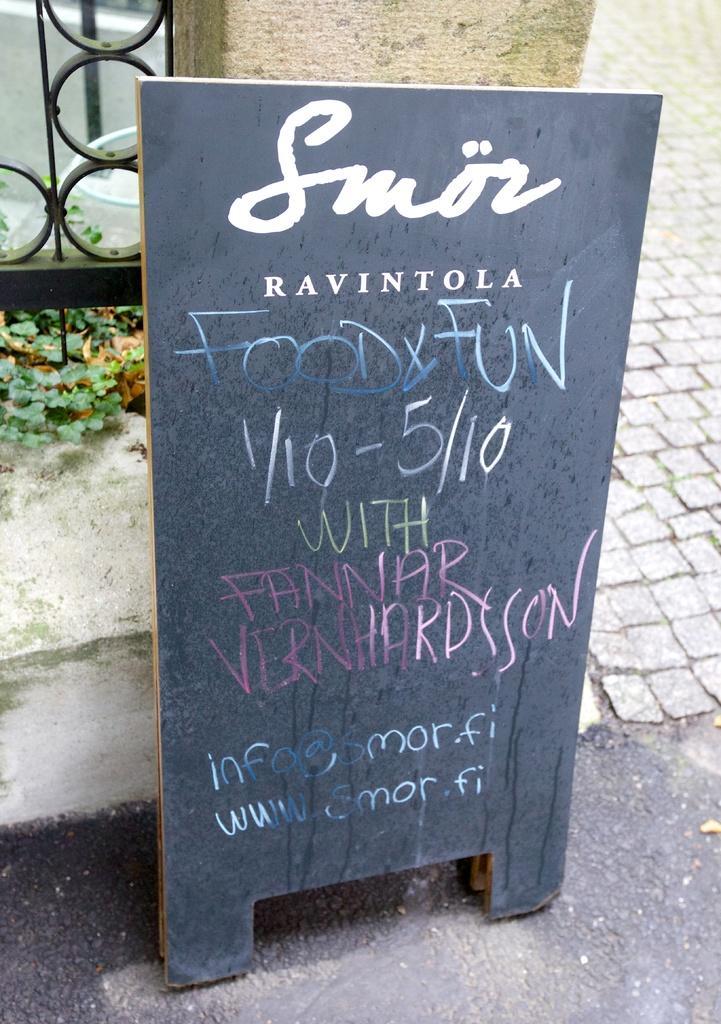Could you give a brief overview of what you see in this image? In this image we can see black board which has food menu on it and in the background of the image there is fencing, some plants and walkway. 